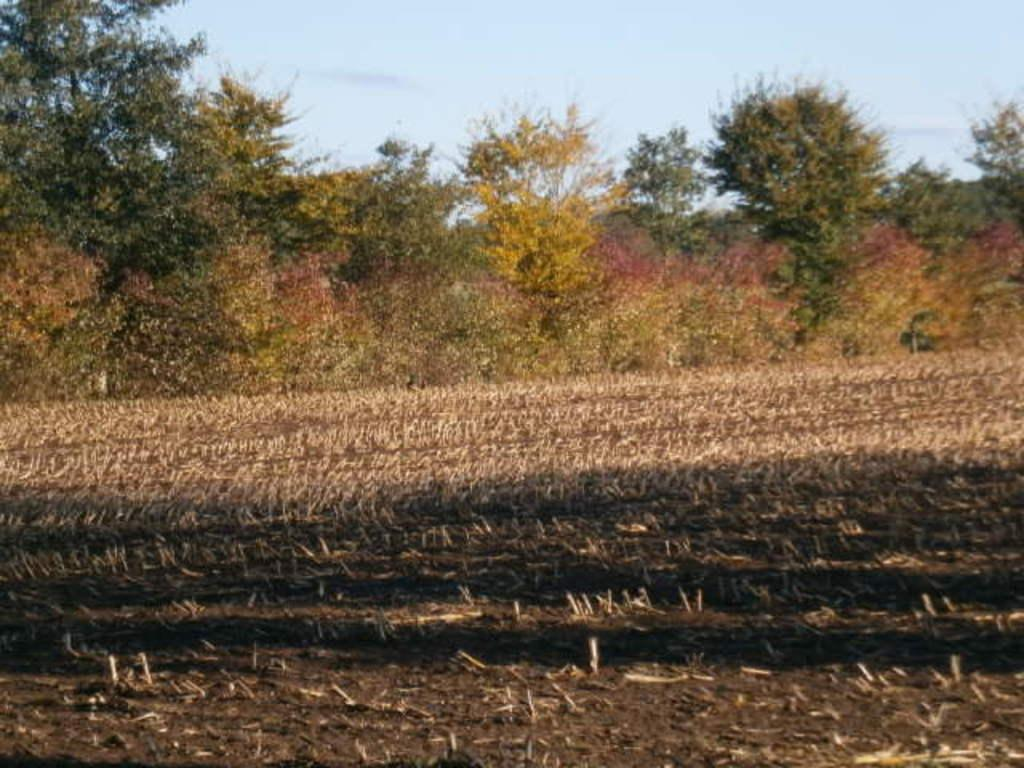What is a natural element visible in the image? The sky is visible in the image. What type of vegetation can be seen in the image? There are trees and plants in the image. What is the ground covered with in the image? Grass is present in the image. How many baby legs are visible in the image? There are no baby legs present in the image. What type of thread is being used to create the plants in the image? There is no thread used to create the plants in the image; they are real plants. 